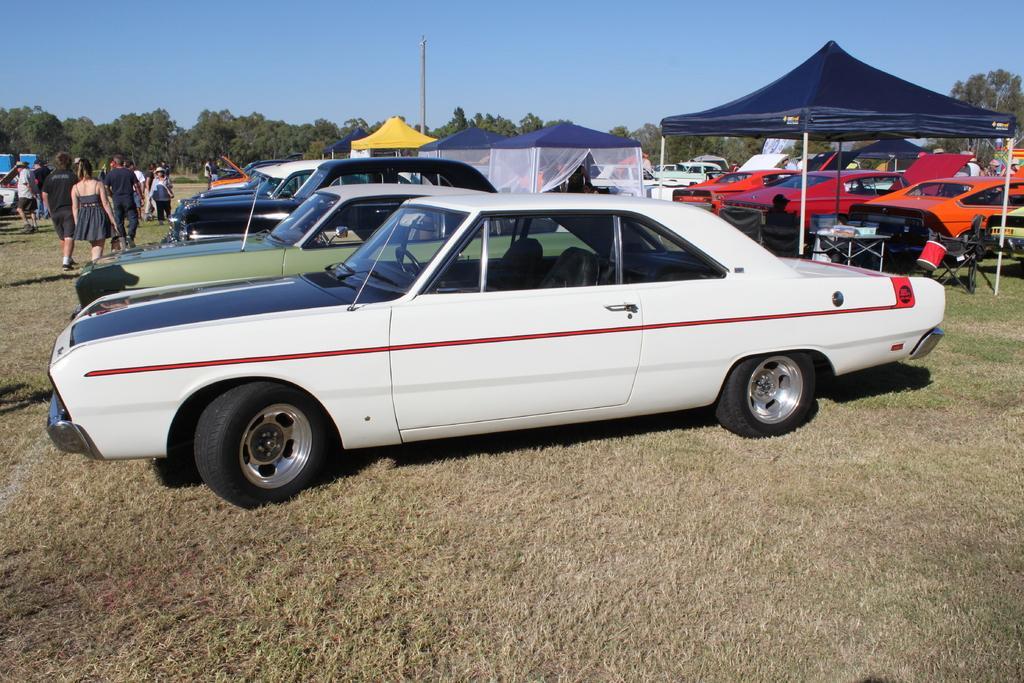Can you describe this image briefly? There are cars and group of people on the ground. Here we can see a pole, tents, and trees. In the background there is sky. 